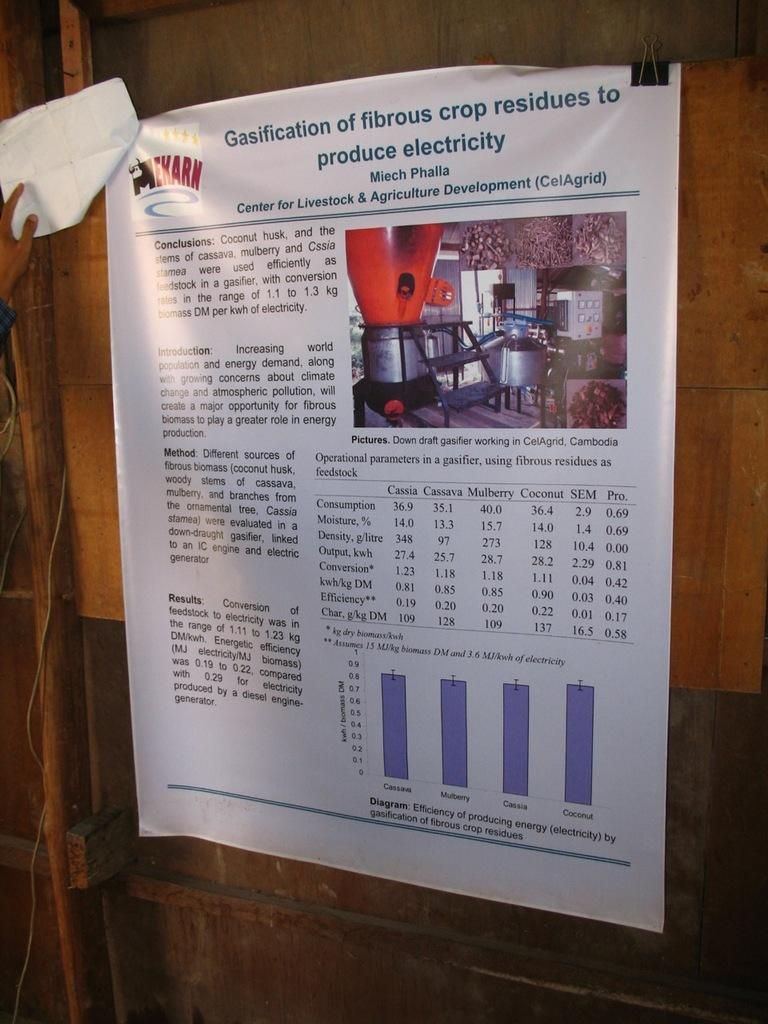<image>
Create a compact narrative representing the image presented. the word electricity is on the white paper 